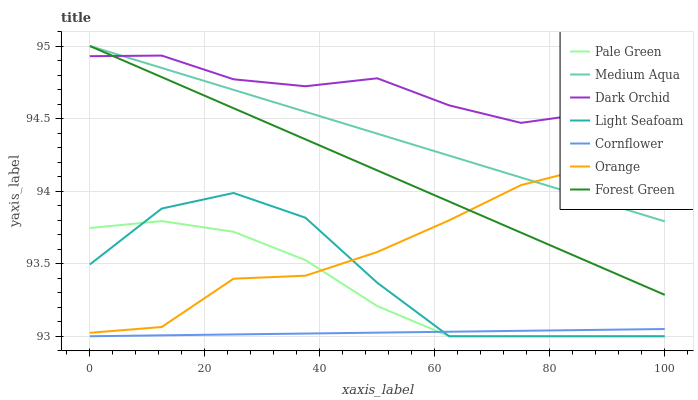Does Cornflower have the minimum area under the curve?
Answer yes or no. Yes. Does Dark Orchid have the maximum area under the curve?
Answer yes or no. Yes. Does Forest Green have the minimum area under the curve?
Answer yes or no. No. Does Forest Green have the maximum area under the curve?
Answer yes or no. No. Is Forest Green the smoothest?
Answer yes or no. Yes. Is Light Seafoam the roughest?
Answer yes or no. Yes. Is Dark Orchid the smoothest?
Answer yes or no. No. Is Dark Orchid the roughest?
Answer yes or no. No. Does Forest Green have the lowest value?
Answer yes or no. No. Does Medium Aqua have the highest value?
Answer yes or no. Yes. Does Dark Orchid have the highest value?
Answer yes or no. No. Is Pale Green less than Medium Aqua?
Answer yes or no. Yes. Is Forest Green greater than Light Seafoam?
Answer yes or no. Yes. Does Light Seafoam intersect Cornflower?
Answer yes or no. Yes. Is Light Seafoam less than Cornflower?
Answer yes or no. No. Is Light Seafoam greater than Cornflower?
Answer yes or no. No. Does Pale Green intersect Medium Aqua?
Answer yes or no. No. 